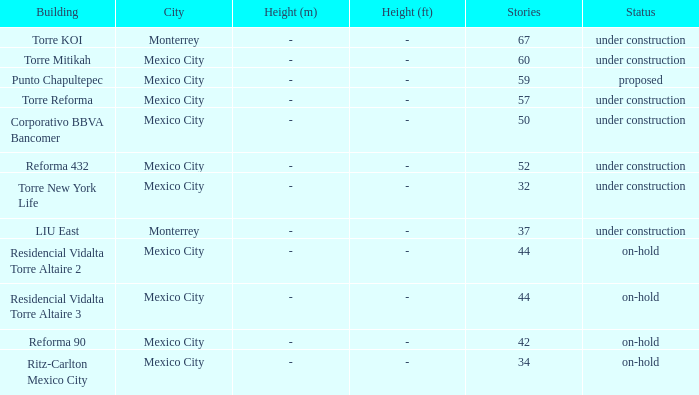What is the number of stories in the torre reforma building? 1.0. 